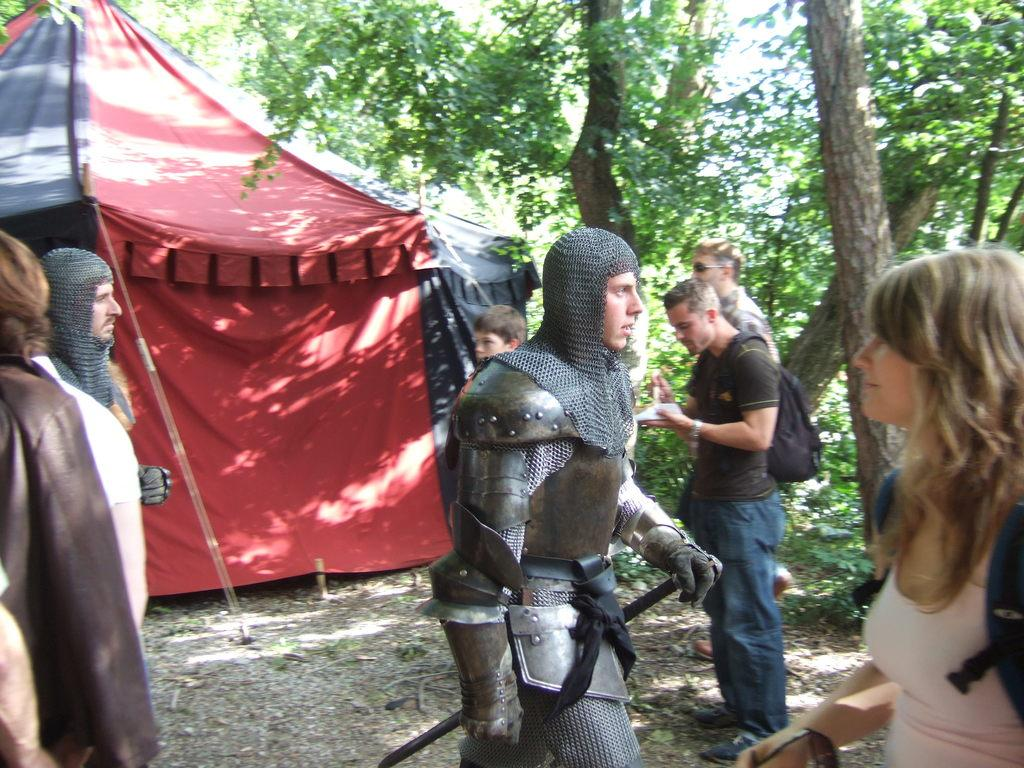What is the main subject in the center of the image? There is a man with a costume in the center of the image. How many people are present in the image? There are many other people in the image besides the man with the costume. What can be seen in the background of the image? There is a tent and trees in the background of the image. Can you describe the person wearing a bag in the image? Yes, there is a person wearing a bag in the image. Where is the bed located in the image? There is no bed present in the image. What type of stick is being used by the man with the costume? The man with the costume is not using a stick in the image. 